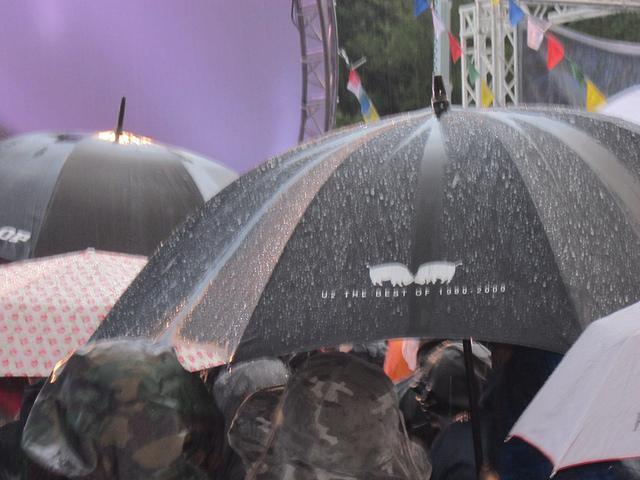What is happening here?
Select the accurate response from the four choices given to answer the question.
Options: Umbrella sale, going home, surprise rain, u2 concert. U2 concert. 